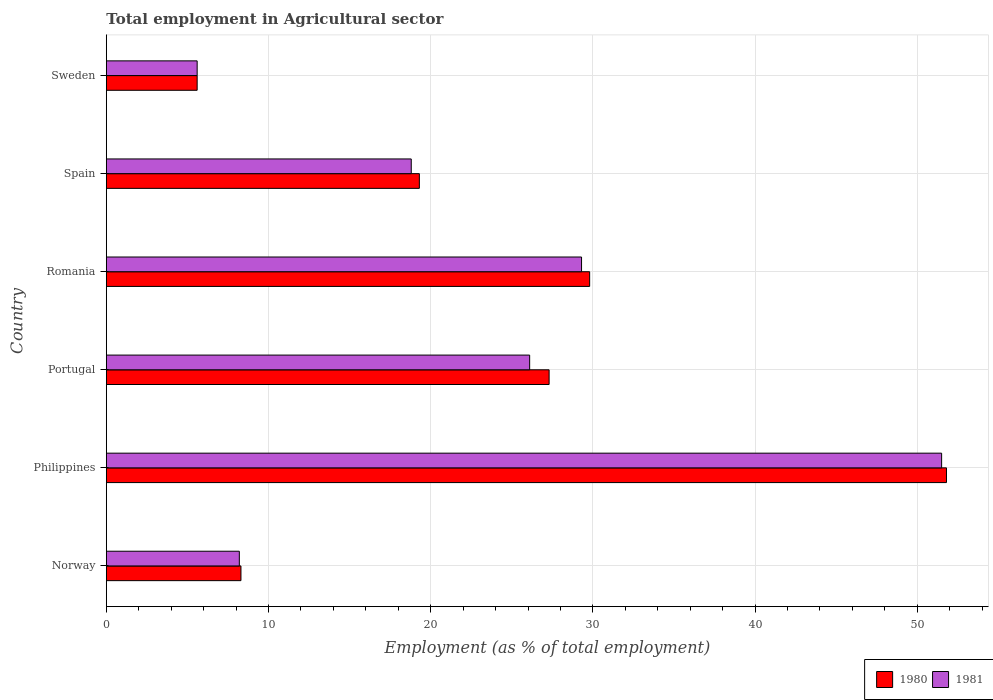How many groups of bars are there?
Offer a very short reply. 6. Are the number of bars per tick equal to the number of legend labels?
Keep it short and to the point. Yes. How many bars are there on the 5th tick from the top?
Make the answer very short. 2. How many bars are there on the 3rd tick from the bottom?
Ensure brevity in your answer.  2. In how many cases, is the number of bars for a given country not equal to the number of legend labels?
Make the answer very short. 0. What is the employment in agricultural sector in 1980 in Spain?
Keep it short and to the point. 19.3. Across all countries, what is the maximum employment in agricultural sector in 1981?
Give a very brief answer. 51.5. Across all countries, what is the minimum employment in agricultural sector in 1980?
Provide a succinct answer. 5.6. In which country was the employment in agricultural sector in 1980 maximum?
Keep it short and to the point. Philippines. In which country was the employment in agricultural sector in 1980 minimum?
Your answer should be compact. Sweden. What is the total employment in agricultural sector in 1980 in the graph?
Offer a terse response. 142.1. What is the difference between the employment in agricultural sector in 1980 in Norway and that in Romania?
Your answer should be very brief. -21.5. What is the difference between the employment in agricultural sector in 1980 in Spain and the employment in agricultural sector in 1981 in Romania?
Keep it short and to the point. -10. What is the average employment in agricultural sector in 1981 per country?
Keep it short and to the point. 23.25. What is the difference between the employment in agricultural sector in 1980 and employment in agricultural sector in 1981 in Norway?
Your answer should be very brief. 0.1. In how many countries, is the employment in agricultural sector in 1981 greater than 4 %?
Offer a very short reply. 6. What is the ratio of the employment in agricultural sector in 1980 in Romania to that in Sweden?
Give a very brief answer. 5.32. What is the difference between the highest and the second highest employment in agricultural sector in 1981?
Make the answer very short. 22.2. What is the difference between the highest and the lowest employment in agricultural sector in 1981?
Make the answer very short. 45.9. Is the sum of the employment in agricultural sector in 1980 in Norway and Sweden greater than the maximum employment in agricultural sector in 1981 across all countries?
Provide a short and direct response. No. How many bars are there?
Provide a succinct answer. 12. Are all the bars in the graph horizontal?
Ensure brevity in your answer.  Yes. How many countries are there in the graph?
Offer a very short reply. 6. What is the difference between two consecutive major ticks on the X-axis?
Give a very brief answer. 10. Are the values on the major ticks of X-axis written in scientific E-notation?
Ensure brevity in your answer.  No. Does the graph contain any zero values?
Offer a terse response. No. Does the graph contain grids?
Your response must be concise. Yes. What is the title of the graph?
Offer a terse response. Total employment in Agricultural sector. Does "2013" appear as one of the legend labels in the graph?
Your answer should be very brief. No. What is the label or title of the X-axis?
Your answer should be compact. Employment (as % of total employment). What is the Employment (as % of total employment) in 1980 in Norway?
Make the answer very short. 8.3. What is the Employment (as % of total employment) in 1981 in Norway?
Your answer should be very brief. 8.2. What is the Employment (as % of total employment) in 1980 in Philippines?
Your answer should be compact. 51.8. What is the Employment (as % of total employment) of 1981 in Philippines?
Your answer should be compact. 51.5. What is the Employment (as % of total employment) of 1980 in Portugal?
Give a very brief answer. 27.3. What is the Employment (as % of total employment) of 1981 in Portugal?
Offer a terse response. 26.1. What is the Employment (as % of total employment) of 1980 in Romania?
Your answer should be very brief. 29.8. What is the Employment (as % of total employment) in 1981 in Romania?
Provide a succinct answer. 29.3. What is the Employment (as % of total employment) in 1980 in Spain?
Keep it short and to the point. 19.3. What is the Employment (as % of total employment) of 1981 in Spain?
Make the answer very short. 18.8. What is the Employment (as % of total employment) of 1980 in Sweden?
Ensure brevity in your answer.  5.6. What is the Employment (as % of total employment) of 1981 in Sweden?
Your response must be concise. 5.6. Across all countries, what is the maximum Employment (as % of total employment) in 1980?
Give a very brief answer. 51.8. Across all countries, what is the maximum Employment (as % of total employment) in 1981?
Give a very brief answer. 51.5. Across all countries, what is the minimum Employment (as % of total employment) of 1980?
Your answer should be very brief. 5.6. Across all countries, what is the minimum Employment (as % of total employment) in 1981?
Ensure brevity in your answer.  5.6. What is the total Employment (as % of total employment) of 1980 in the graph?
Offer a very short reply. 142.1. What is the total Employment (as % of total employment) in 1981 in the graph?
Ensure brevity in your answer.  139.5. What is the difference between the Employment (as % of total employment) in 1980 in Norway and that in Philippines?
Your answer should be compact. -43.5. What is the difference between the Employment (as % of total employment) of 1981 in Norway and that in Philippines?
Give a very brief answer. -43.3. What is the difference between the Employment (as % of total employment) of 1980 in Norway and that in Portugal?
Keep it short and to the point. -19. What is the difference between the Employment (as % of total employment) of 1981 in Norway and that in Portugal?
Offer a very short reply. -17.9. What is the difference between the Employment (as % of total employment) in 1980 in Norway and that in Romania?
Offer a very short reply. -21.5. What is the difference between the Employment (as % of total employment) of 1981 in Norway and that in Romania?
Ensure brevity in your answer.  -21.1. What is the difference between the Employment (as % of total employment) of 1980 in Norway and that in Spain?
Offer a terse response. -11. What is the difference between the Employment (as % of total employment) in 1981 in Norway and that in Spain?
Give a very brief answer. -10.6. What is the difference between the Employment (as % of total employment) of 1981 in Philippines and that in Portugal?
Make the answer very short. 25.4. What is the difference between the Employment (as % of total employment) in 1981 in Philippines and that in Romania?
Offer a very short reply. 22.2. What is the difference between the Employment (as % of total employment) of 1980 in Philippines and that in Spain?
Your response must be concise. 32.5. What is the difference between the Employment (as % of total employment) in 1981 in Philippines and that in Spain?
Your answer should be very brief. 32.7. What is the difference between the Employment (as % of total employment) in 1980 in Philippines and that in Sweden?
Give a very brief answer. 46.2. What is the difference between the Employment (as % of total employment) in 1981 in Philippines and that in Sweden?
Offer a terse response. 45.9. What is the difference between the Employment (as % of total employment) in 1980 in Portugal and that in Romania?
Make the answer very short. -2.5. What is the difference between the Employment (as % of total employment) of 1981 in Portugal and that in Romania?
Offer a terse response. -3.2. What is the difference between the Employment (as % of total employment) in 1980 in Portugal and that in Sweden?
Keep it short and to the point. 21.7. What is the difference between the Employment (as % of total employment) of 1981 in Romania and that in Spain?
Provide a short and direct response. 10.5. What is the difference between the Employment (as % of total employment) of 1980 in Romania and that in Sweden?
Give a very brief answer. 24.2. What is the difference between the Employment (as % of total employment) in 1981 in Romania and that in Sweden?
Keep it short and to the point. 23.7. What is the difference between the Employment (as % of total employment) of 1980 in Spain and that in Sweden?
Offer a terse response. 13.7. What is the difference between the Employment (as % of total employment) of 1981 in Spain and that in Sweden?
Make the answer very short. 13.2. What is the difference between the Employment (as % of total employment) of 1980 in Norway and the Employment (as % of total employment) of 1981 in Philippines?
Your answer should be very brief. -43.2. What is the difference between the Employment (as % of total employment) in 1980 in Norway and the Employment (as % of total employment) in 1981 in Portugal?
Provide a succinct answer. -17.8. What is the difference between the Employment (as % of total employment) in 1980 in Norway and the Employment (as % of total employment) in 1981 in Romania?
Your answer should be very brief. -21. What is the difference between the Employment (as % of total employment) of 1980 in Norway and the Employment (as % of total employment) of 1981 in Spain?
Give a very brief answer. -10.5. What is the difference between the Employment (as % of total employment) in 1980 in Philippines and the Employment (as % of total employment) in 1981 in Portugal?
Ensure brevity in your answer.  25.7. What is the difference between the Employment (as % of total employment) in 1980 in Philippines and the Employment (as % of total employment) in 1981 in Romania?
Your response must be concise. 22.5. What is the difference between the Employment (as % of total employment) of 1980 in Philippines and the Employment (as % of total employment) of 1981 in Spain?
Your answer should be compact. 33. What is the difference between the Employment (as % of total employment) of 1980 in Philippines and the Employment (as % of total employment) of 1981 in Sweden?
Keep it short and to the point. 46.2. What is the difference between the Employment (as % of total employment) in 1980 in Portugal and the Employment (as % of total employment) in 1981 in Romania?
Your answer should be very brief. -2. What is the difference between the Employment (as % of total employment) in 1980 in Portugal and the Employment (as % of total employment) in 1981 in Sweden?
Provide a short and direct response. 21.7. What is the difference between the Employment (as % of total employment) in 1980 in Romania and the Employment (as % of total employment) in 1981 in Sweden?
Provide a succinct answer. 24.2. What is the average Employment (as % of total employment) in 1980 per country?
Offer a very short reply. 23.68. What is the average Employment (as % of total employment) of 1981 per country?
Make the answer very short. 23.25. What is the difference between the Employment (as % of total employment) in 1980 and Employment (as % of total employment) in 1981 in Norway?
Ensure brevity in your answer.  0.1. What is the difference between the Employment (as % of total employment) in 1980 and Employment (as % of total employment) in 1981 in Portugal?
Give a very brief answer. 1.2. What is the difference between the Employment (as % of total employment) in 1980 and Employment (as % of total employment) in 1981 in Romania?
Your answer should be very brief. 0.5. What is the ratio of the Employment (as % of total employment) in 1980 in Norway to that in Philippines?
Provide a succinct answer. 0.16. What is the ratio of the Employment (as % of total employment) of 1981 in Norway to that in Philippines?
Make the answer very short. 0.16. What is the ratio of the Employment (as % of total employment) in 1980 in Norway to that in Portugal?
Make the answer very short. 0.3. What is the ratio of the Employment (as % of total employment) of 1981 in Norway to that in Portugal?
Your answer should be very brief. 0.31. What is the ratio of the Employment (as % of total employment) of 1980 in Norway to that in Romania?
Give a very brief answer. 0.28. What is the ratio of the Employment (as % of total employment) in 1981 in Norway to that in Romania?
Provide a short and direct response. 0.28. What is the ratio of the Employment (as % of total employment) of 1980 in Norway to that in Spain?
Make the answer very short. 0.43. What is the ratio of the Employment (as % of total employment) of 1981 in Norway to that in Spain?
Offer a very short reply. 0.44. What is the ratio of the Employment (as % of total employment) of 1980 in Norway to that in Sweden?
Offer a terse response. 1.48. What is the ratio of the Employment (as % of total employment) in 1981 in Norway to that in Sweden?
Offer a terse response. 1.46. What is the ratio of the Employment (as % of total employment) in 1980 in Philippines to that in Portugal?
Your answer should be very brief. 1.9. What is the ratio of the Employment (as % of total employment) of 1981 in Philippines to that in Portugal?
Ensure brevity in your answer.  1.97. What is the ratio of the Employment (as % of total employment) in 1980 in Philippines to that in Romania?
Offer a very short reply. 1.74. What is the ratio of the Employment (as % of total employment) of 1981 in Philippines to that in Romania?
Ensure brevity in your answer.  1.76. What is the ratio of the Employment (as % of total employment) of 1980 in Philippines to that in Spain?
Your answer should be compact. 2.68. What is the ratio of the Employment (as % of total employment) of 1981 in Philippines to that in Spain?
Offer a terse response. 2.74. What is the ratio of the Employment (as % of total employment) in 1980 in Philippines to that in Sweden?
Offer a terse response. 9.25. What is the ratio of the Employment (as % of total employment) of 1981 in Philippines to that in Sweden?
Your answer should be very brief. 9.2. What is the ratio of the Employment (as % of total employment) of 1980 in Portugal to that in Romania?
Give a very brief answer. 0.92. What is the ratio of the Employment (as % of total employment) in 1981 in Portugal to that in Romania?
Provide a succinct answer. 0.89. What is the ratio of the Employment (as % of total employment) of 1980 in Portugal to that in Spain?
Offer a very short reply. 1.41. What is the ratio of the Employment (as % of total employment) in 1981 in Portugal to that in Spain?
Offer a terse response. 1.39. What is the ratio of the Employment (as % of total employment) of 1980 in Portugal to that in Sweden?
Provide a short and direct response. 4.88. What is the ratio of the Employment (as % of total employment) in 1981 in Portugal to that in Sweden?
Make the answer very short. 4.66. What is the ratio of the Employment (as % of total employment) of 1980 in Romania to that in Spain?
Provide a short and direct response. 1.54. What is the ratio of the Employment (as % of total employment) in 1981 in Romania to that in Spain?
Offer a terse response. 1.56. What is the ratio of the Employment (as % of total employment) in 1980 in Romania to that in Sweden?
Ensure brevity in your answer.  5.32. What is the ratio of the Employment (as % of total employment) in 1981 in Romania to that in Sweden?
Your answer should be very brief. 5.23. What is the ratio of the Employment (as % of total employment) of 1980 in Spain to that in Sweden?
Your answer should be compact. 3.45. What is the ratio of the Employment (as % of total employment) in 1981 in Spain to that in Sweden?
Offer a terse response. 3.36. What is the difference between the highest and the second highest Employment (as % of total employment) in 1980?
Your answer should be compact. 22. What is the difference between the highest and the second highest Employment (as % of total employment) in 1981?
Give a very brief answer. 22.2. What is the difference between the highest and the lowest Employment (as % of total employment) in 1980?
Your response must be concise. 46.2. What is the difference between the highest and the lowest Employment (as % of total employment) in 1981?
Your response must be concise. 45.9. 